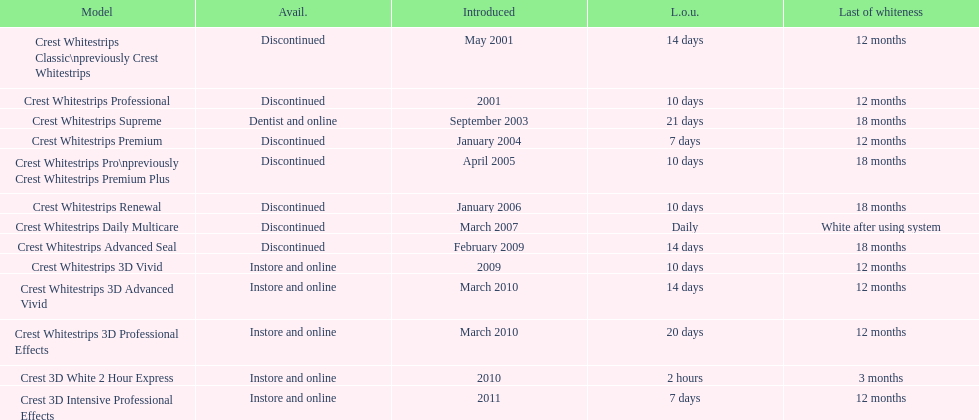What is the duration of the sustained whiteness effect for both crest 3d intensive professional effects and crest whitestrips 3d professional effects, in months? 12 months. 